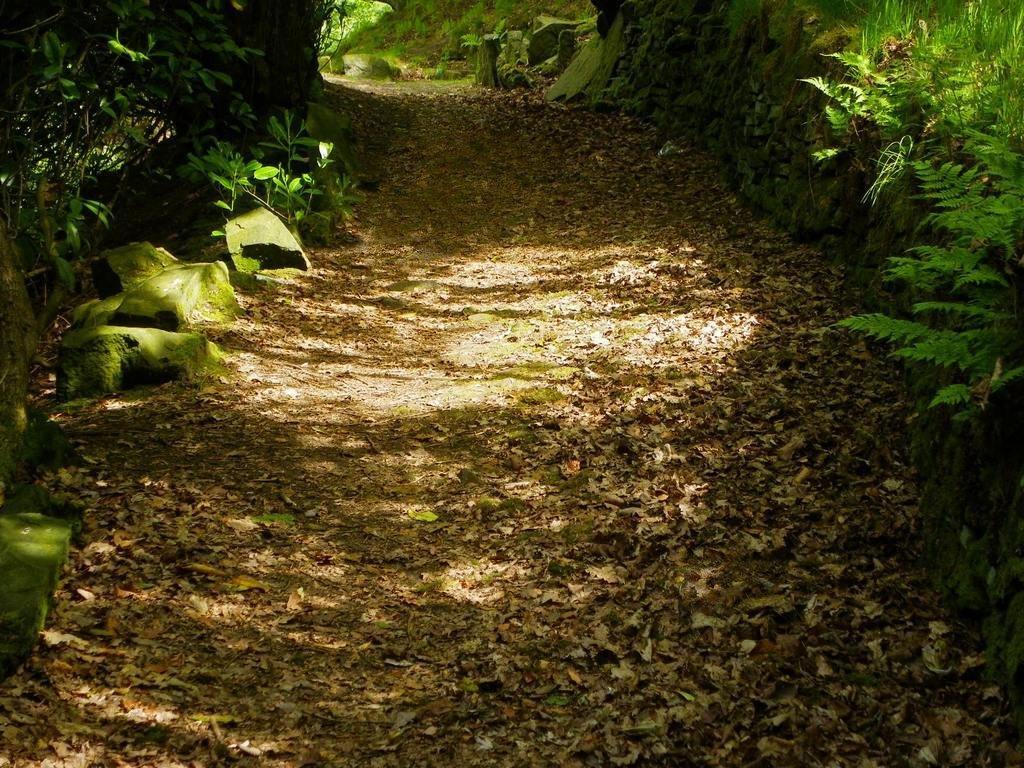How would you summarize this image in a sentence or two? In this image there is a path. There are dried leaves on the path. On the either sides of the path there are rocks and plants. There is algae on the rocks. 